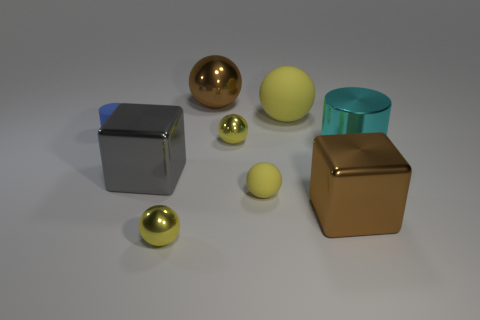There is a cylinder left of the big cyan metallic object; what material is it?
Provide a short and direct response. Rubber. The gray object that is the same material as the brown sphere is what size?
Offer a very short reply. Large. There is a large cyan metal thing; are there any big metallic things in front of it?
Provide a succinct answer. Yes. What is the size of the other rubber thing that is the same shape as the big yellow thing?
Your response must be concise. Small. There is a small rubber ball; does it have the same color as the metal sphere in front of the large gray shiny object?
Make the answer very short. Yes. Does the big matte sphere have the same color as the tiny rubber sphere?
Give a very brief answer. Yes. Are there fewer large metal cubes than small yellow objects?
Offer a very short reply. Yes. How many other things are there of the same color as the large metal sphere?
Keep it short and to the point. 1. What number of large purple metal balls are there?
Provide a succinct answer. 0. Is the number of large cyan metallic cylinders behind the brown metallic ball less than the number of cyan shiny objects?
Make the answer very short. Yes. 